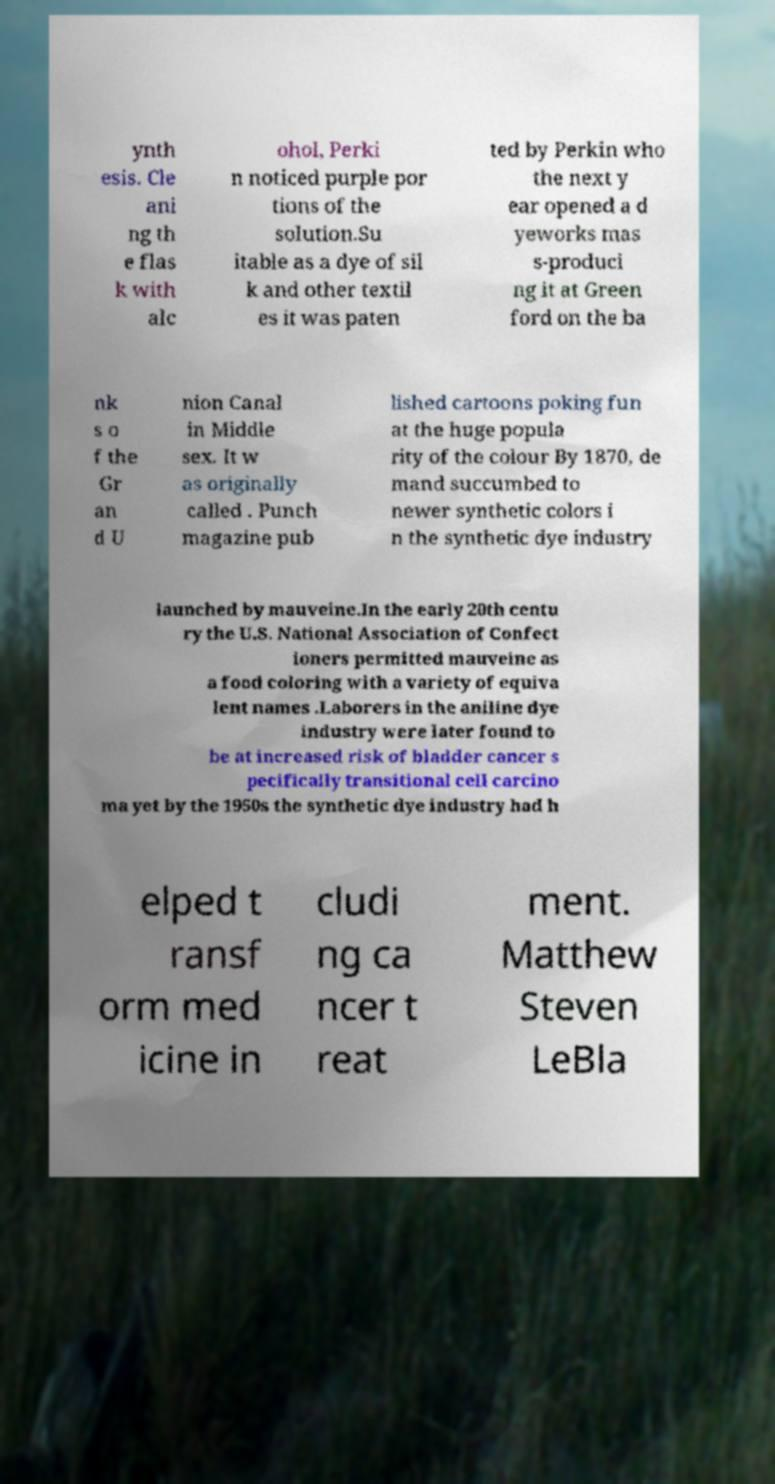Could you assist in decoding the text presented in this image and type it out clearly? ynth esis. Cle ani ng th e flas k with alc ohol, Perki n noticed purple por tions of the solution.Su itable as a dye of sil k and other textil es it was paten ted by Perkin who the next y ear opened a d yeworks mas s-produci ng it at Green ford on the ba nk s o f the Gr an d U nion Canal in Middle sex. It w as originally called . Punch magazine pub lished cartoons poking fun at the huge popula rity of the colour By 1870, de mand succumbed to newer synthetic colors i n the synthetic dye industry launched by mauveine.In the early 20th centu ry the U.S. National Association of Confect ioners permitted mauveine as a food coloring with a variety of equiva lent names .Laborers in the aniline dye industry were later found to be at increased risk of bladder cancer s pecifically transitional cell carcino ma yet by the 1950s the synthetic dye industry had h elped t ransf orm med icine in cludi ng ca ncer t reat ment. Matthew Steven LeBla 